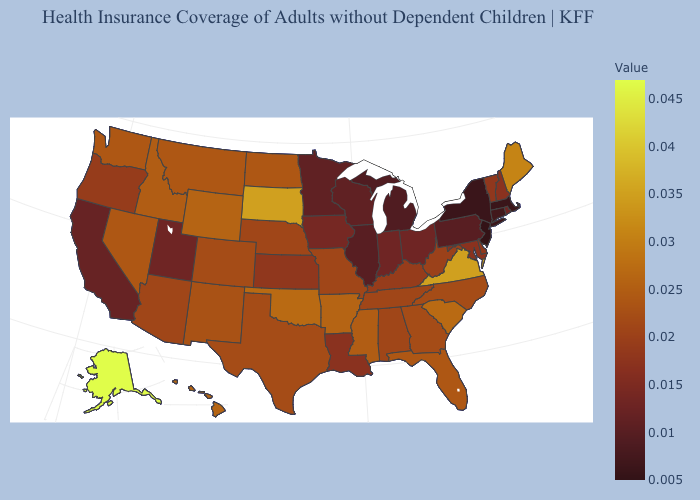Among the states that border Vermont , does Massachusetts have the lowest value?
Short answer required. Yes. Which states have the lowest value in the USA?
Concise answer only. New Jersey. Which states hav the highest value in the West?
Be succinct. Alaska. Is the legend a continuous bar?
Short answer required. Yes. 